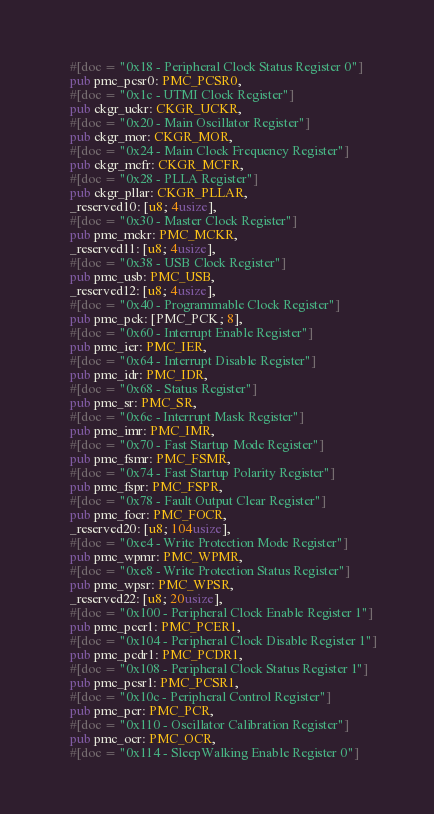<code> <loc_0><loc_0><loc_500><loc_500><_Rust_>    #[doc = "0x18 - Peripheral Clock Status Register 0"]
    pub pmc_pcsr0: PMC_PCSR0,
    #[doc = "0x1c - UTMI Clock Register"]
    pub ckgr_uckr: CKGR_UCKR,
    #[doc = "0x20 - Main Oscillator Register"]
    pub ckgr_mor: CKGR_MOR,
    #[doc = "0x24 - Main Clock Frequency Register"]
    pub ckgr_mcfr: CKGR_MCFR,
    #[doc = "0x28 - PLLA Register"]
    pub ckgr_pllar: CKGR_PLLAR,
    _reserved10: [u8; 4usize],
    #[doc = "0x30 - Master Clock Register"]
    pub pmc_mckr: PMC_MCKR,
    _reserved11: [u8; 4usize],
    #[doc = "0x38 - USB Clock Register"]
    pub pmc_usb: PMC_USB,
    _reserved12: [u8; 4usize],
    #[doc = "0x40 - Programmable Clock Register"]
    pub pmc_pck: [PMC_PCK; 8],
    #[doc = "0x60 - Interrupt Enable Register"]
    pub pmc_ier: PMC_IER,
    #[doc = "0x64 - Interrupt Disable Register"]
    pub pmc_idr: PMC_IDR,
    #[doc = "0x68 - Status Register"]
    pub pmc_sr: PMC_SR,
    #[doc = "0x6c - Interrupt Mask Register"]
    pub pmc_imr: PMC_IMR,
    #[doc = "0x70 - Fast Startup Mode Register"]
    pub pmc_fsmr: PMC_FSMR,
    #[doc = "0x74 - Fast Startup Polarity Register"]
    pub pmc_fspr: PMC_FSPR,
    #[doc = "0x78 - Fault Output Clear Register"]
    pub pmc_focr: PMC_FOCR,
    _reserved20: [u8; 104usize],
    #[doc = "0xe4 - Write Protection Mode Register"]
    pub pmc_wpmr: PMC_WPMR,
    #[doc = "0xe8 - Write Protection Status Register"]
    pub pmc_wpsr: PMC_WPSR,
    _reserved22: [u8; 20usize],
    #[doc = "0x100 - Peripheral Clock Enable Register 1"]
    pub pmc_pcer1: PMC_PCER1,
    #[doc = "0x104 - Peripheral Clock Disable Register 1"]
    pub pmc_pcdr1: PMC_PCDR1,
    #[doc = "0x108 - Peripheral Clock Status Register 1"]
    pub pmc_pcsr1: PMC_PCSR1,
    #[doc = "0x10c - Peripheral Control Register"]
    pub pmc_pcr: PMC_PCR,
    #[doc = "0x110 - Oscillator Calibration Register"]
    pub pmc_ocr: PMC_OCR,
    #[doc = "0x114 - SleepWalking Enable Register 0"]</code> 